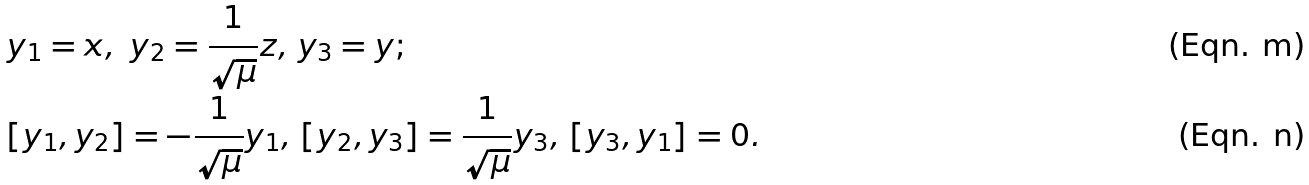<formula> <loc_0><loc_0><loc_500><loc_500>& y _ { 1 } = x , \ y _ { 2 } = \frac { 1 } { \sqrt { \mu } } z , \, y _ { 3 } = y ; \\ & [ y _ { 1 } , y _ { 2 } ] = - \frac { 1 } { \sqrt { \mu } } y _ { 1 } , \, [ y _ { 2 } , y _ { 3 } ] = \frac { 1 } { \sqrt { \mu } } y _ { 3 } , \, [ y _ { 3 } , y _ { 1 } ] = 0 .</formula> 